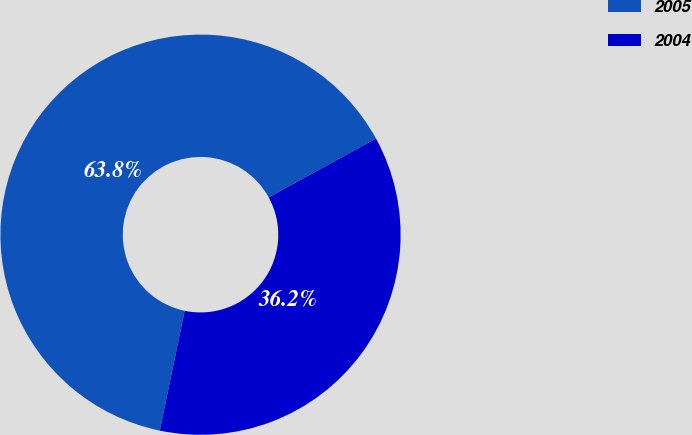Convert chart. <chart><loc_0><loc_0><loc_500><loc_500><pie_chart><fcel>2005<fcel>2004<nl><fcel>63.76%<fcel>36.24%<nl></chart> 